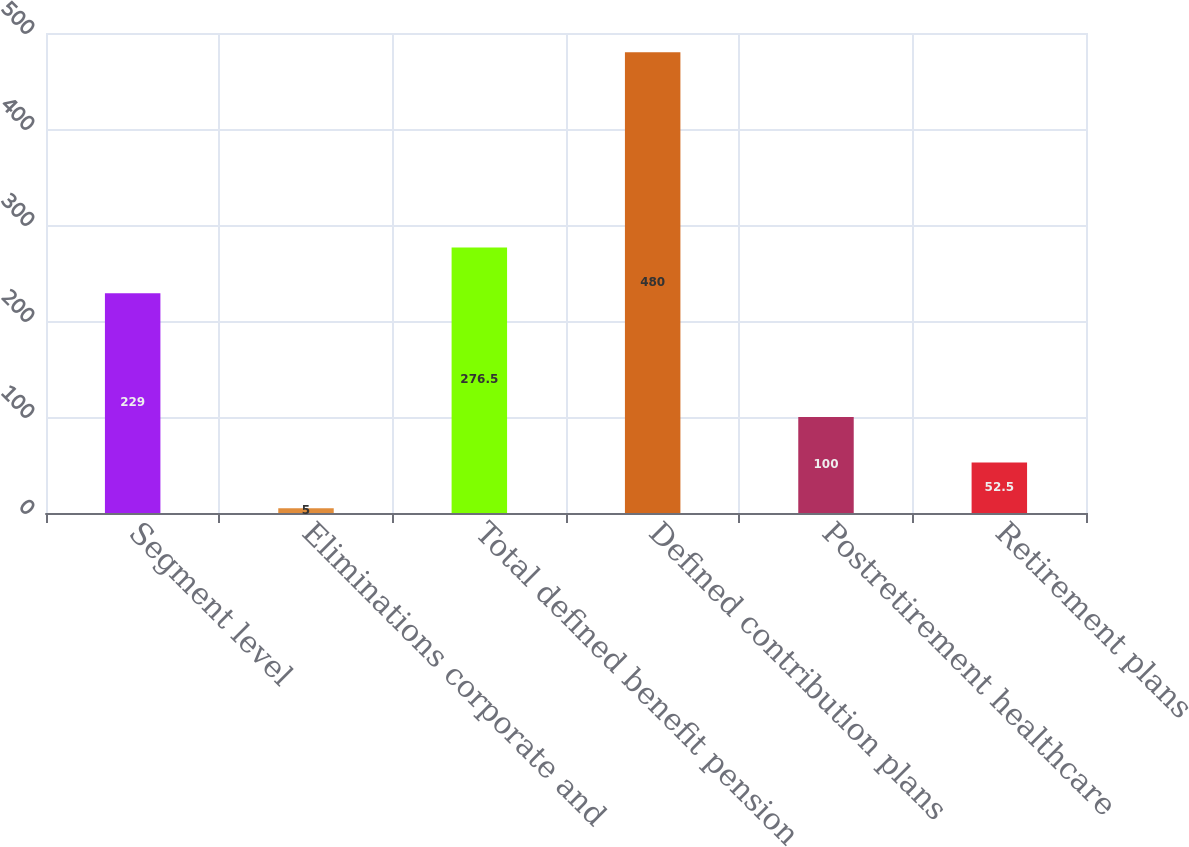Convert chart to OTSL. <chart><loc_0><loc_0><loc_500><loc_500><bar_chart><fcel>Segment level<fcel>Eliminations corporate and<fcel>Total defined benefit pension<fcel>Defined contribution plans<fcel>Postretirement healthcare<fcel>Retirement plans<nl><fcel>229<fcel>5<fcel>276.5<fcel>480<fcel>100<fcel>52.5<nl></chart> 